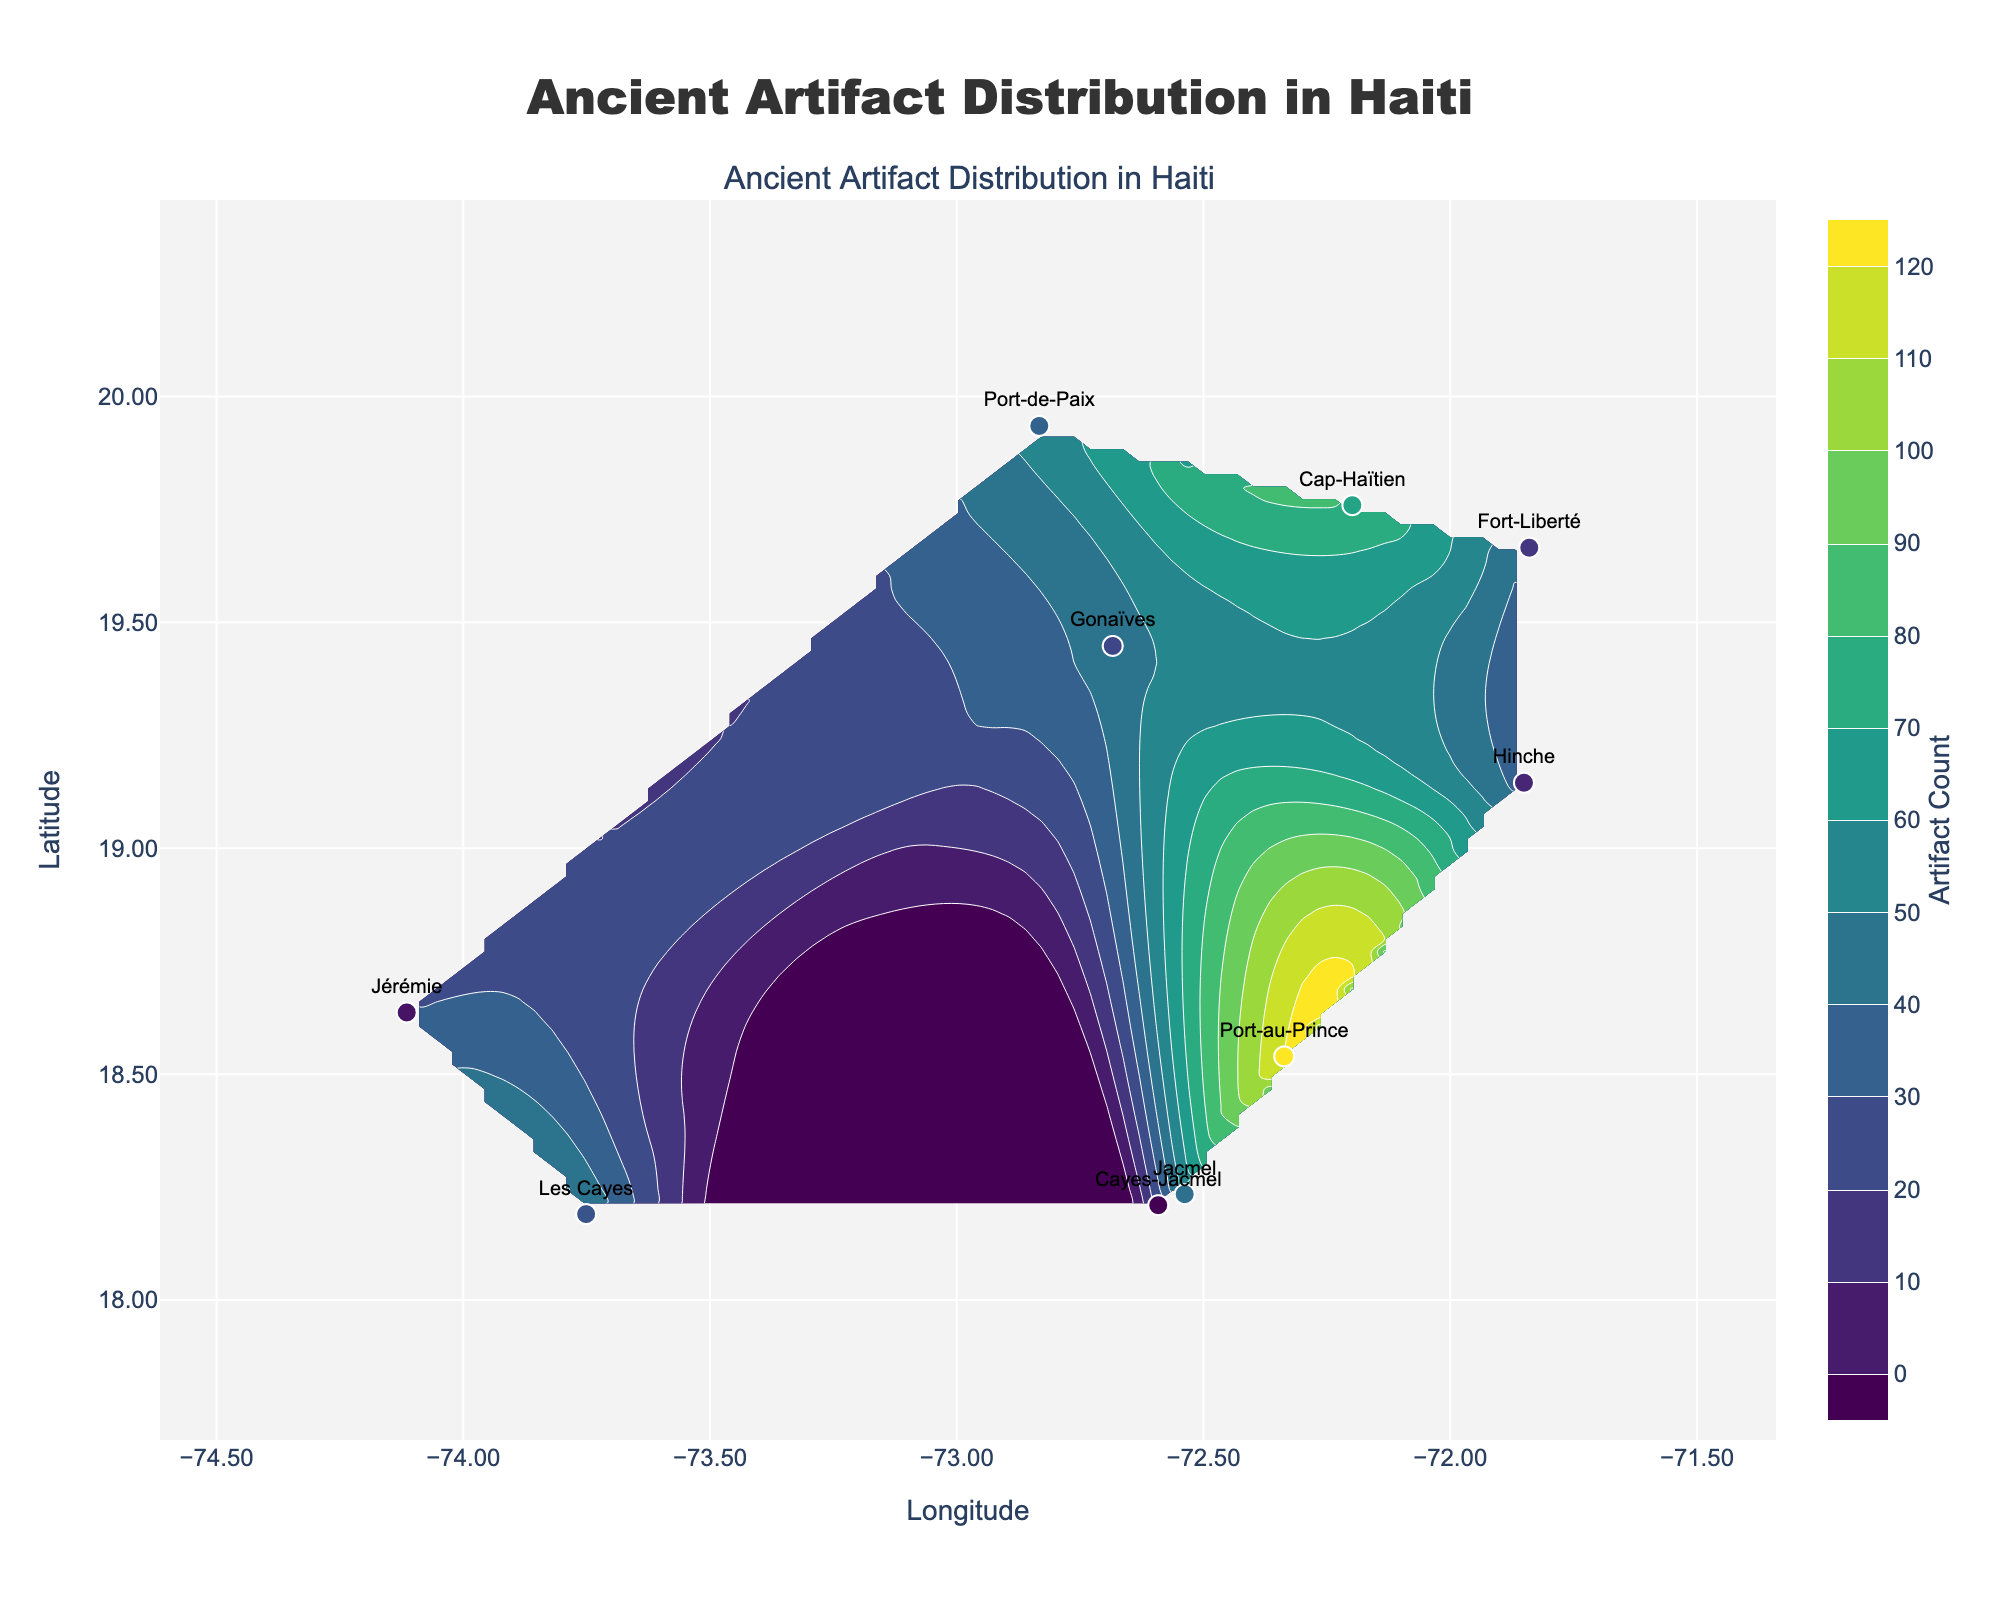What's the title of the plot? The title of the plot is displayed prominently at the top center of the figure with large font size. The title reads "Ancient Artifact Distribution in Haiti".
Answer: Ancient Artifact Distribution in Haiti What do the x and y axes represent? The x-axis at the bottom represents Longitude and the y-axis on the left represents Latitude. These axes are labeled clearly in the figure.
Answer: Longitude (x-axis) and Latitude (y-axis) Which region has the highest artifact count? By looking at the scatter plot markers, the region with the highest artifact count is represented by the largest and the most colorful marker. "Port-au-Prince" marker indicates the highest value with an artifact count of 120.
Answer: Port-au-Prince Which regions show moderate artifact counts, between 50 and 80? We need to look for scatter markers with artifact counts that are between 50 and 80. "Cap-Haïtien" (80), "Les Cayes" (50), and "Jacmel" (60) fall into this range.
Answer: Cap-Haïtien, Les Cayes, Jacmel Where are the contour lines the densest, indicating higher artifact concentration? In a contour plot, denser contour lines indicate higher concentration. The densest contour lines can be seen near the latitude and longitude corresponding to "Port-au-Prince".
Answer: Near Port-au-Prince What is the approximate range of artifact counts displayed in the color bar? The color bar on the right of the plot shows the gradient for artifact counts. By inspecting it, the range starts around 0 and ends at the maximum value displayed, which is 120.
Answer: 0 to 120 How many regions are shown in the plot? Each scatter marker represents a region. Counting the scatter markers, there are 10 regions plotted.
Answer: 10 Which region has the lowest artifact count? By examining the region with the smallest marker size and the lowest color intensity, "Cayes-Jacmel" with an artifact count of 25 is the region with the lowest count.
Answer: Cayes-Jacmel Comparing Port-au-Prince and Jérémie, which one has a higher artifact count and by how much? "Port-au-Prince" has an artifact count of 120, while "Jérémie" has 30. The difference in artifact counts between these regions is 120 - 30 = 90.
Answer: Port-au-Prince by 90 Is there any region with artifact counts between 30 and 40? If yes, name it. Observing the scatter markers within the specified range, "Hinche" has an artifact count of 35, and "Fort-Liberté" has an artifact count of 40.
Answer: Hinche and Fort-Liberté 